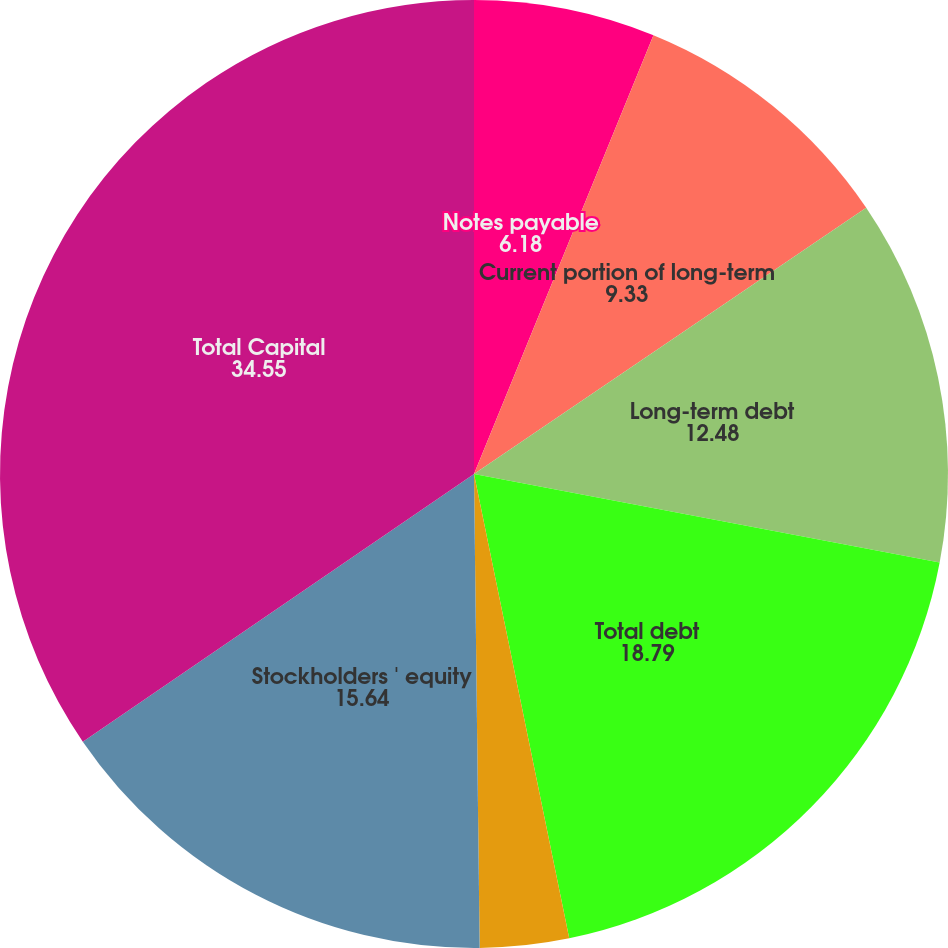<chart> <loc_0><loc_0><loc_500><loc_500><pie_chart><fcel>Notes payable<fcel>Current portion of long-term<fcel>Long-term debt<fcel>Total debt<fcel>Minority interests<fcel>Stockholders ' equity<fcel>Total Capital<nl><fcel>6.18%<fcel>9.33%<fcel>12.48%<fcel>18.79%<fcel>3.03%<fcel>15.64%<fcel>34.55%<nl></chart> 